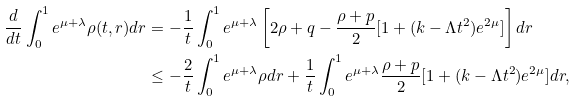<formula> <loc_0><loc_0><loc_500><loc_500>\frac { d } { d t } \int _ { 0 } ^ { 1 } e ^ { \mu + \lambda } \rho ( t , r ) d r & = - \frac { 1 } { t } \int _ { 0 } ^ { 1 } e ^ { \mu + \lambda } \left [ 2 \rho + q - \frac { \rho + p } { 2 } [ 1 + ( k - \Lambda t ^ { 2 } ) e ^ { 2 \mu } ] \right ] d r \\ & \leq - \frac { 2 } { t } \int _ { 0 } ^ { 1 } e ^ { \mu + \lambda } \rho d r + \frac { 1 } { t } \int _ { 0 } ^ { 1 } e ^ { \mu + \lambda } \frac { \rho + p } { 2 } [ 1 + ( k - \Lambda t ^ { 2 } ) e ^ { 2 \mu } ] d r ,</formula> 